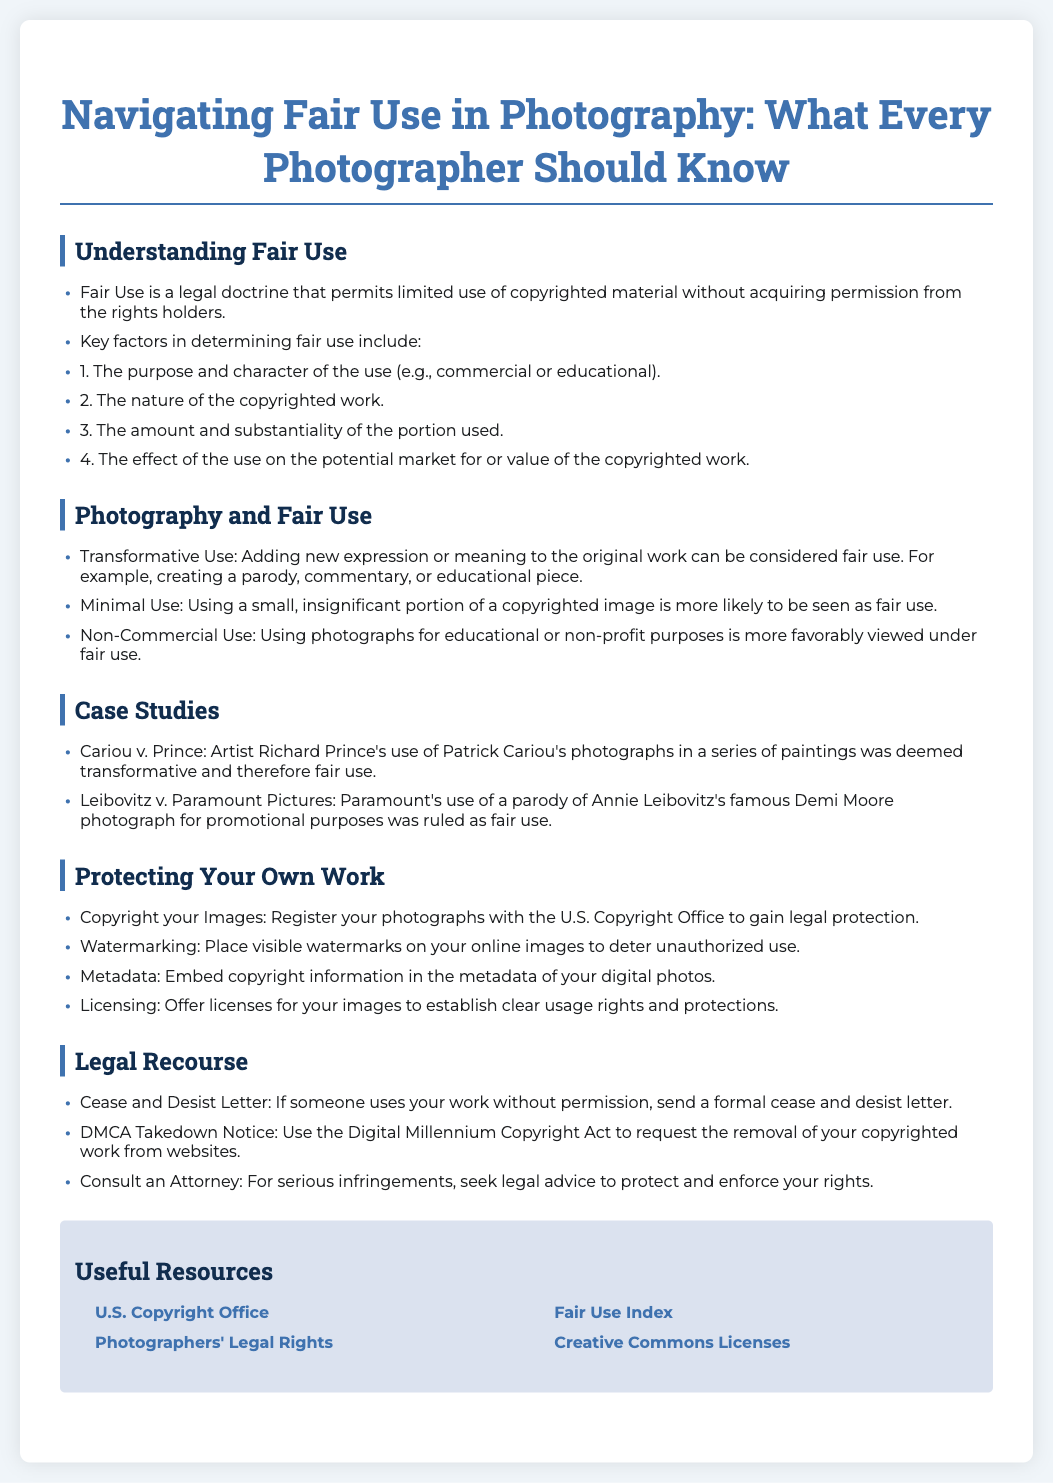What is Fair Use? Fair Use is a legal doctrine that permits limited use of copyrighted material without acquiring permission from the rights holders.
Answer: A legal doctrine What are the four key factors in determining fair use? The key factors are the purpose and character of the use, the nature of the copyrighted work, the amount and substantiality of the portion used, and the effect on the potential market.
Answer: Four key factors What case involved Patrick Cariou's photographs? The case is Cariou v. Prince.
Answer: Cariou v. Prince What is a recommended way to protect your images? Copyright your Images: Register your photographs with the U.S. Copyright Office to gain legal protection.
Answer: Copyright your Images What should you do if someone uses your work without permission? Send a formal cease and desist letter.
Answer: Cease and Desist Letter What type of use is more likely to be seen as fair use? Using a small, insignificant portion of a copyrighted image.
Answer: Minimal Use What legal act can you use to request removal of your copyrighted work? The Digital Millennium Copyright Act.
Answer: DMCA Takedown Notice What is one way to deter unauthorized use of your images? Place visible watermarks on your online images.
Answer: Watermarking What resource provides information on photographers' legal rights? Cornell Law School website.
Answer: Photographers' Legal Rights 